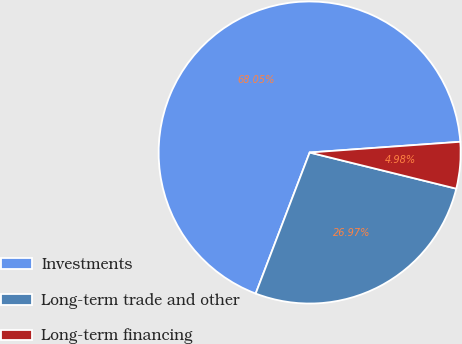<chart> <loc_0><loc_0><loc_500><loc_500><pie_chart><fcel>Investments<fcel>Long-term trade and other<fcel>Long-term financing<nl><fcel>68.06%<fcel>26.97%<fcel>4.98%<nl></chart> 